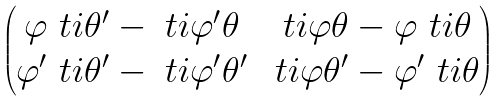<formula> <loc_0><loc_0><loc_500><loc_500>\begin{pmatrix} \varphi \ t i \theta ^ { \prime } - \ t i \varphi ^ { \prime } \theta & \ t i \varphi \theta - \varphi \ t i \theta \\ \varphi ^ { \prime } \ t i \theta ^ { \prime } - \ t i \varphi ^ { \prime } \theta ^ { \prime } & \ t i \varphi \theta ^ { \prime } - \varphi ^ { \prime } \ t i \theta \\ \end{pmatrix}</formula> 